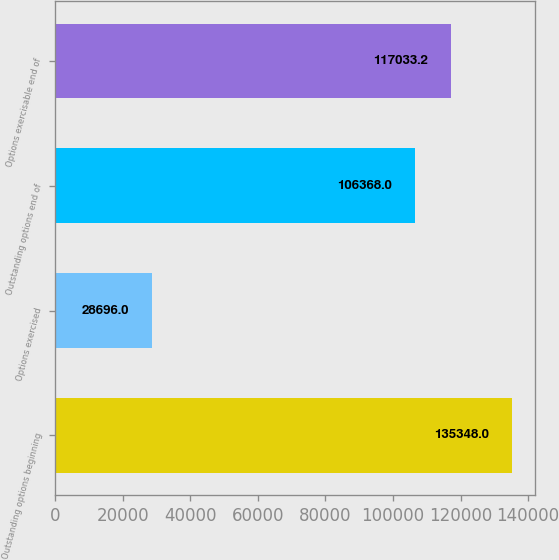Convert chart. <chart><loc_0><loc_0><loc_500><loc_500><bar_chart><fcel>Outstanding options beginning<fcel>Options exercised<fcel>Outstanding options end of<fcel>Options exercisable end of<nl><fcel>135348<fcel>28696<fcel>106368<fcel>117033<nl></chart> 